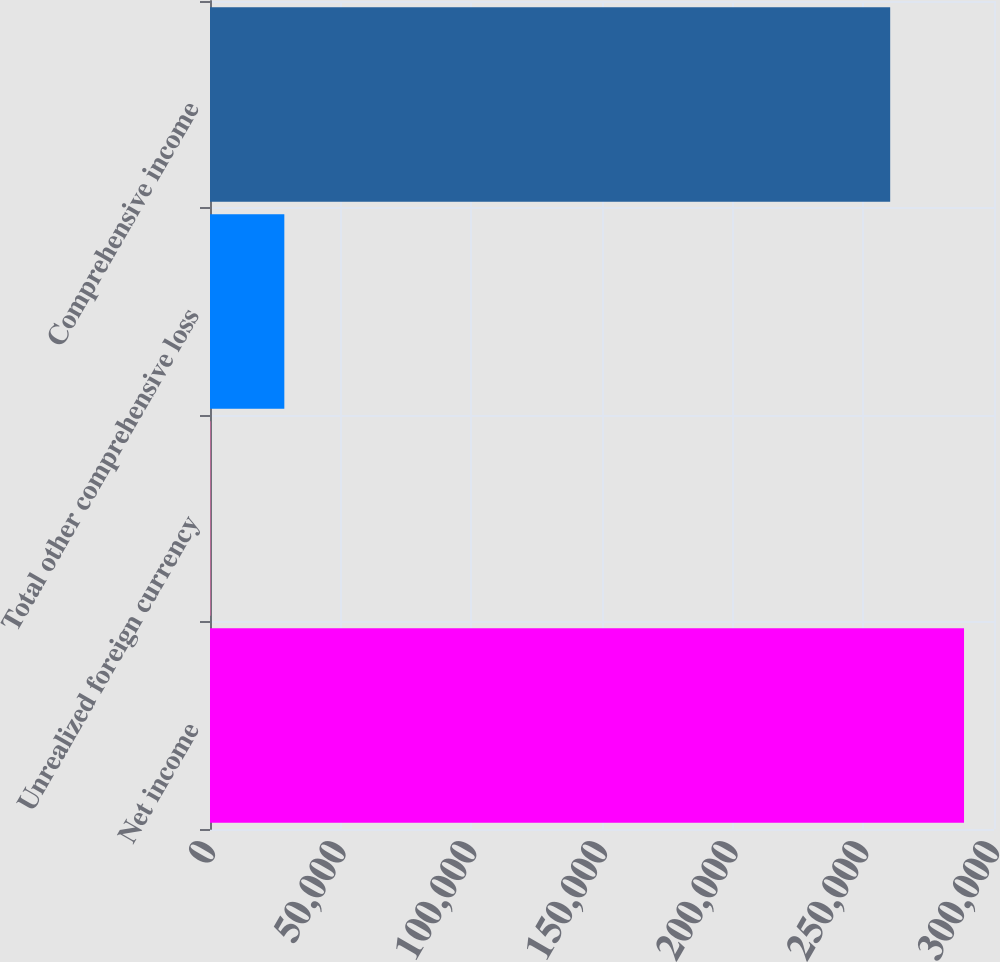<chart> <loc_0><loc_0><loc_500><loc_500><bar_chart><fcel>Net income<fcel>Unrealized foreign currency<fcel>Total other comprehensive loss<fcel>Comprehensive income<nl><fcel>288532<fcel>183<fcel>28440.5<fcel>260274<nl></chart> 